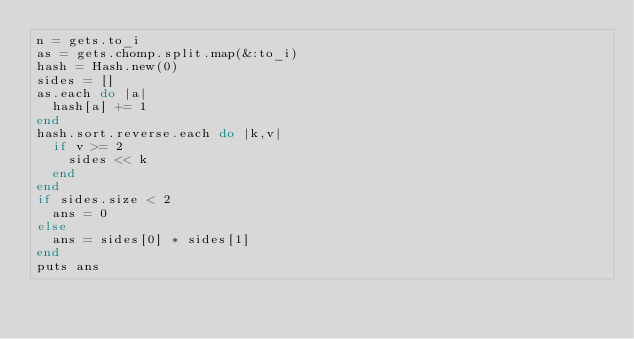<code> <loc_0><loc_0><loc_500><loc_500><_Ruby_>n = gets.to_i
as = gets.chomp.split.map(&:to_i)
hash = Hash.new(0)
sides = []
as.each do |a|
  hash[a] += 1
end
hash.sort.reverse.each do |k,v|
  if v >= 2
    sides << k
  end
end
if sides.size < 2
  ans = 0
else
  ans = sides[0] * sides[1]
end
puts ans</code> 